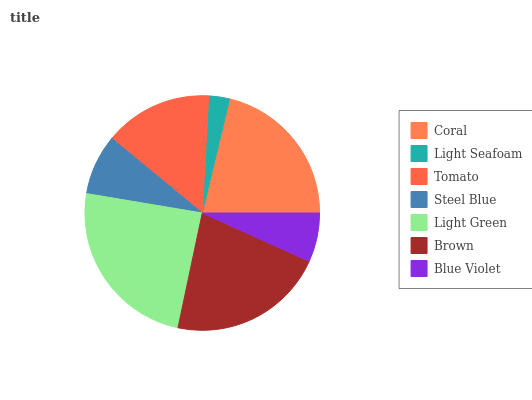Is Light Seafoam the minimum?
Answer yes or no. Yes. Is Light Green the maximum?
Answer yes or no. Yes. Is Tomato the minimum?
Answer yes or no. No. Is Tomato the maximum?
Answer yes or no. No. Is Tomato greater than Light Seafoam?
Answer yes or no. Yes. Is Light Seafoam less than Tomato?
Answer yes or no. Yes. Is Light Seafoam greater than Tomato?
Answer yes or no. No. Is Tomato less than Light Seafoam?
Answer yes or no. No. Is Tomato the high median?
Answer yes or no. Yes. Is Tomato the low median?
Answer yes or no. Yes. Is Light Green the high median?
Answer yes or no. No. Is Light Green the low median?
Answer yes or no. No. 